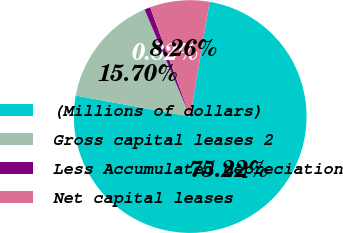Convert chart. <chart><loc_0><loc_0><loc_500><loc_500><pie_chart><fcel>(Millions of dollars)<fcel>Gross capital leases 2<fcel>Less Accumulated depreciation<fcel>Net capital leases<nl><fcel>75.22%<fcel>15.7%<fcel>0.82%<fcel>8.26%<nl></chart> 